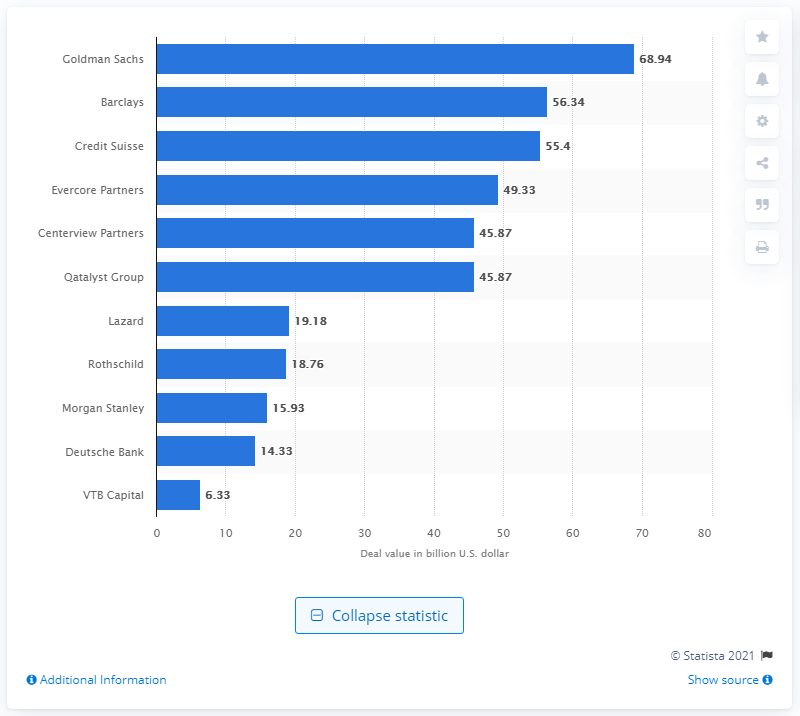Outline some significant characteristics in this image. In 2016, the deal value for Goldman Sachs was approximately $68.94. It is known that Goldman Sachs was the leading advisor to M&A deals in the Benelux countries in 2016. 